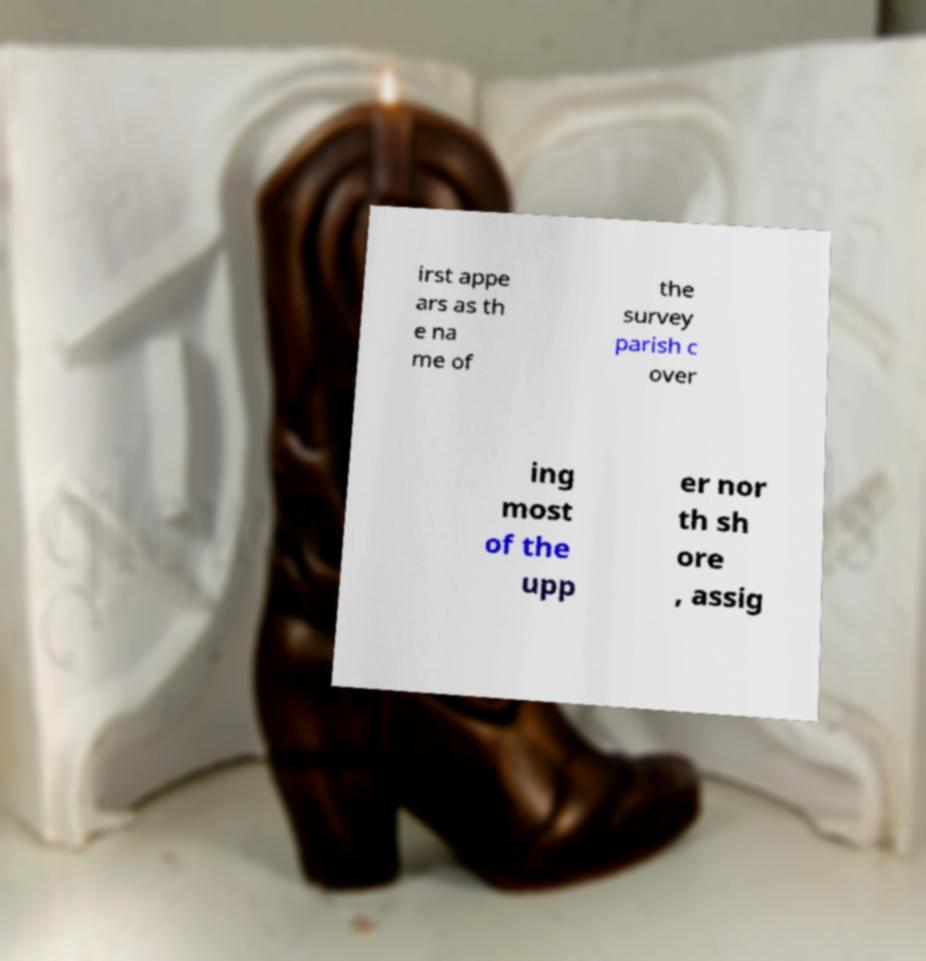There's text embedded in this image that I need extracted. Can you transcribe it verbatim? irst appe ars as th e na me of the survey parish c over ing most of the upp er nor th sh ore , assig 